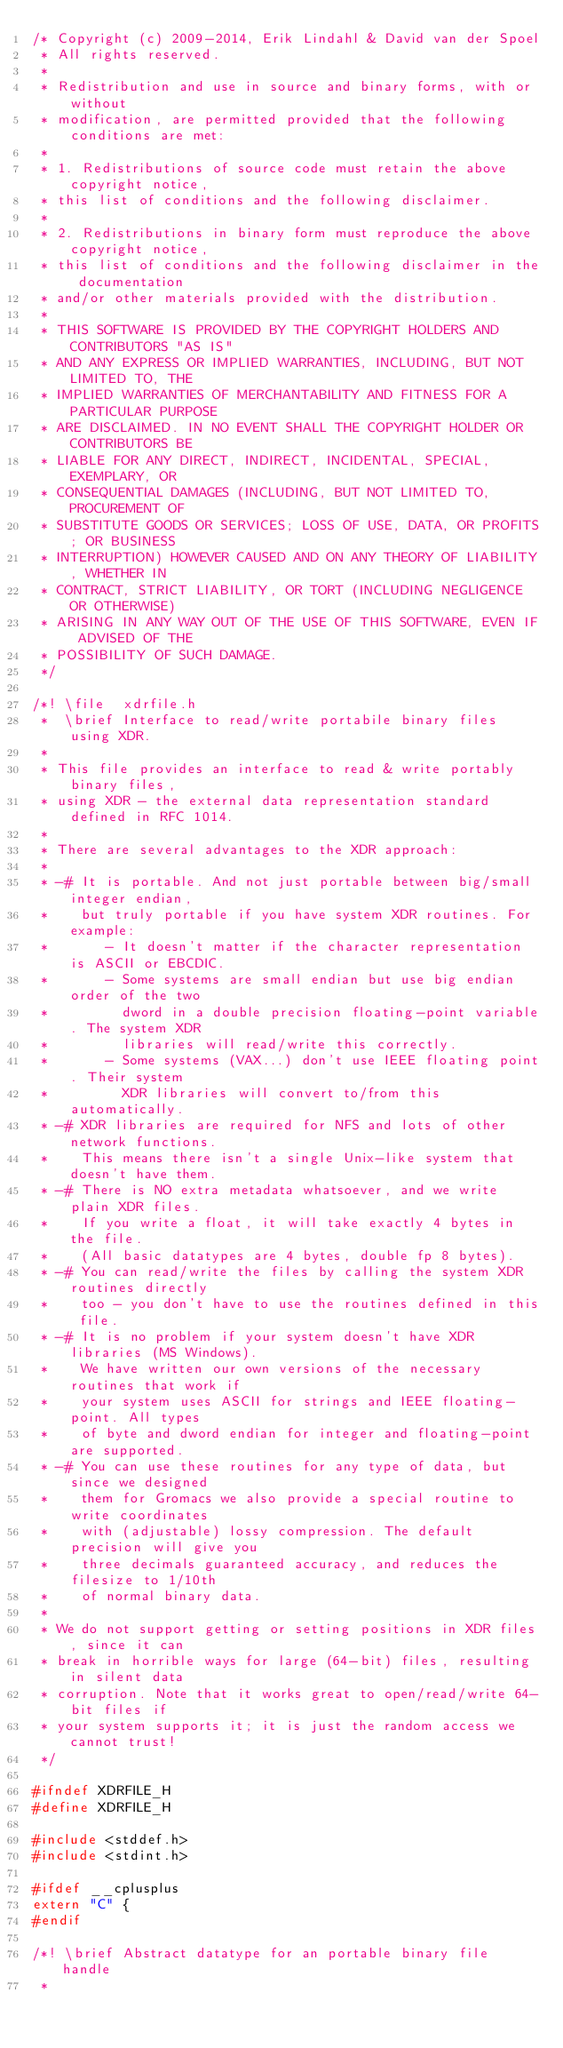<code> <loc_0><loc_0><loc_500><loc_500><_C_>/* Copyright (c) 2009-2014, Erik Lindahl & David van der Spoel
 * All rights reserved.
 *
 * Redistribution and use in source and binary forms, with or without
 * modification, are permitted provided that the following conditions are met:
 *
 * 1. Redistributions of source code must retain the above copyright notice,
 * this list of conditions and the following disclaimer.
 *
 * 2. Redistributions in binary form must reproduce the above copyright notice,
 * this list of conditions and the following disclaimer in the documentation
 * and/or other materials provided with the distribution.
 *
 * THIS SOFTWARE IS PROVIDED BY THE COPYRIGHT HOLDERS AND CONTRIBUTORS "AS IS"
 * AND ANY EXPRESS OR IMPLIED WARRANTIES, INCLUDING, BUT NOT LIMITED TO, THE
 * IMPLIED WARRANTIES OF MERCHANTABILITY AND FITNESS FOR A PARTICULAR PURPOSE
 * ARE DISCLAIMED. IN NO EVENT SHALL THE COPYRIGHT HOLDER OR CONTRIBUTORS BE
 * LIABLE FOR ANY DIRECT, INDIRECT, INCIDENTAL, SPECIAL, EXEMPLARY, OR
 * CONSEQUENTIAL DAMAGES (INCLUDING, BUT NOT LIMITED TO, PROCUREMENT OF
 * SUBSTITUTE GOODS OR SERVICES; LOSS OF USE, DATA, OR PROFITS; OR BUSINESS
 * INTERRUPTION) HOWEVER CAUSED AND ON ANY THEORY OF LIABILITY, WHETHER IN
 * CONTRACT, STRICT LIABILITY, OR TORT (INCLUDING NEGLIGENCE OR OTHERWISE)
 * ARISING IN ANY WAY OUT OF THE USE OF THIS SOFTWARE, EVEN IF ADVISED OF THE
 * POSSIBILITY OF SUCH DAMAGE.
 */

/*! \file  xdrfile.h
 *  \brief Interface to read/write portabile binary files using XDR.
 *
 * This file provides an interface to read & write portably binary files,
 * using XDR - the external data representation standard defined in RFC 1014.
 *
 * There are several advantages to the XDR approach:
 *
 * -# It is portable. And not just portable between big/small integer endian,
 *    but truly portable if you have system XDR routines. For example:
 *       - It doesn't matter if the character representation is ASCII or EBCDIC.
 *       - Some systems are small endian but use big endian order of the two
 *         dword in a double precision floating-point variable. The system XDR
 *         libraries will read/write this correctly.
 *       - Some systems (VAX...) don't use IEEE floating point. Their system
 *         XDR libraries will convert to/from this automatically.
 * -# XDR libraries are required for NFS and lots of other network functions.
 *    This means there isn't a single Unix-like system that doesn't have them.
 * -# There is NO extra metadata whatsoever, and we write plain XDR files.
 *    If you write a float, it will take exactly 4 bytes in the file.
 *    (All basic datatypes are 4 bytes, double fp 8 bytes).
 * -# You can read/write the files by calling the system XDR routines directly
 *    too - you don't have to use the routines defined in this file.
 * -# It is no problem if your system doesn't have XDR libraries (MS Windows).
 *    We have written our own versions of the necessary routines that work if
 *    your system uses ASCII for strings and IEEE floating-point. All types
 *    of byte and dword endian for integer and floating-point are supported.
 * -# You can use these routines for any type of data, but since we designed
 *    them for Gromacs we also provide a special routine to write coordinates
 *    with (adjustable) lossy compression. The default precision will give you
 *    three decimals guaranteed accuracy, and reduces the filesize to 1/10th
 *    of normal binary data.
 *
 * We do not support getting or setting positions in XDR files, since it can
 * break in horrible ways for large (64-bit) files, resulting in silent data
 * corruption. Note that it works great to open/read/write 64-bit files if
 * your system supports it; it is just the random access we cannot trust!
 */

#ifndef XDRFILE_H
#define XDRFILE_H

#include <stddef.h>
#include <stdint.h>

#ifdef __cplusplus
extern "C" {
#endif

/*! \brief Abstract datatype for an portable binary file handle
 *</code> 